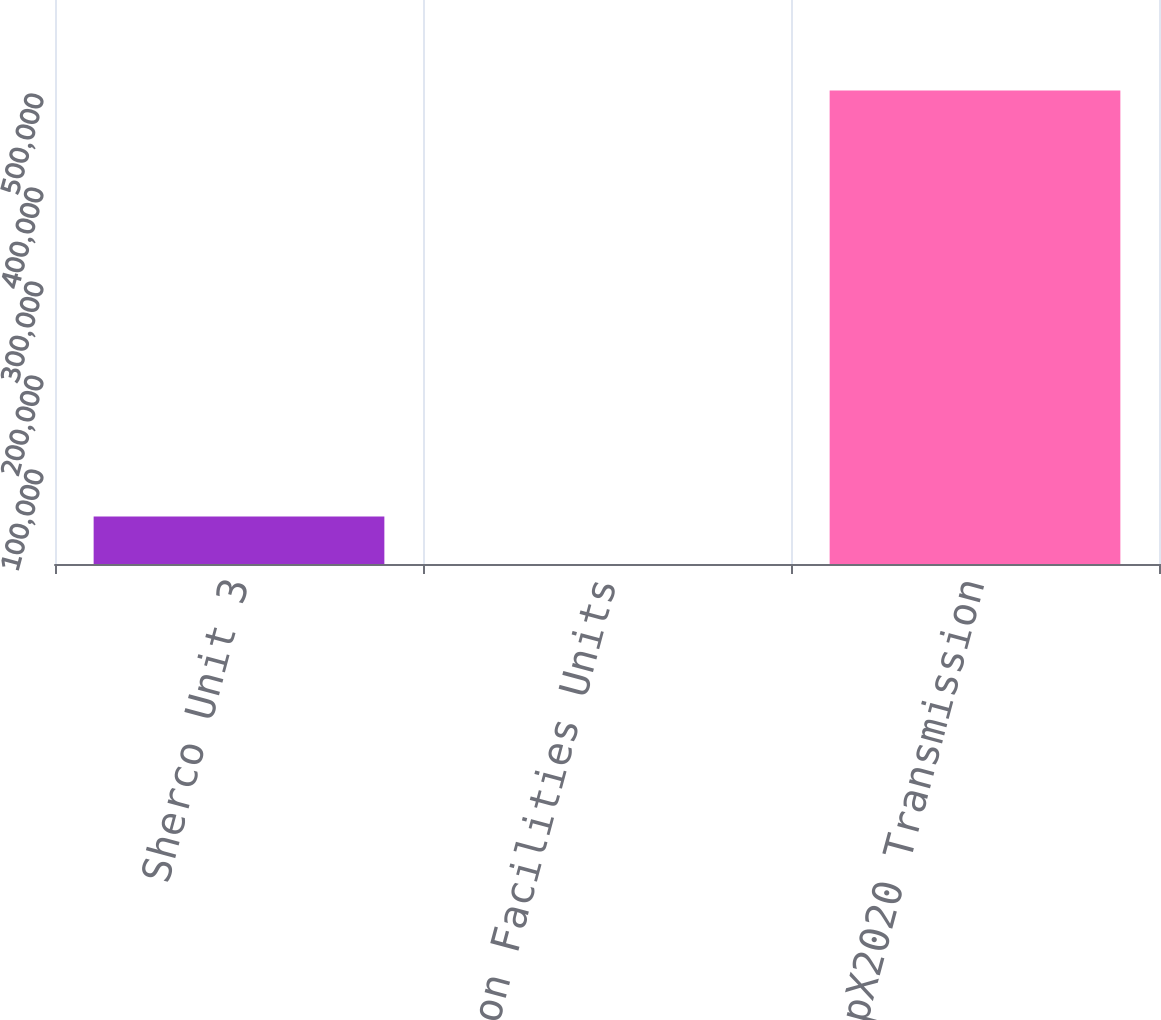<chart> <loc_0><loc_0><loc_500><loc_500><bar_chart><fcel>Sherco Unit 3<fcel>Sherco Common Facilities Units<fcel>CapX2020 Transmission<nl><fcel>50426.3<fcel>61<fcel>503714<nl></chart> 